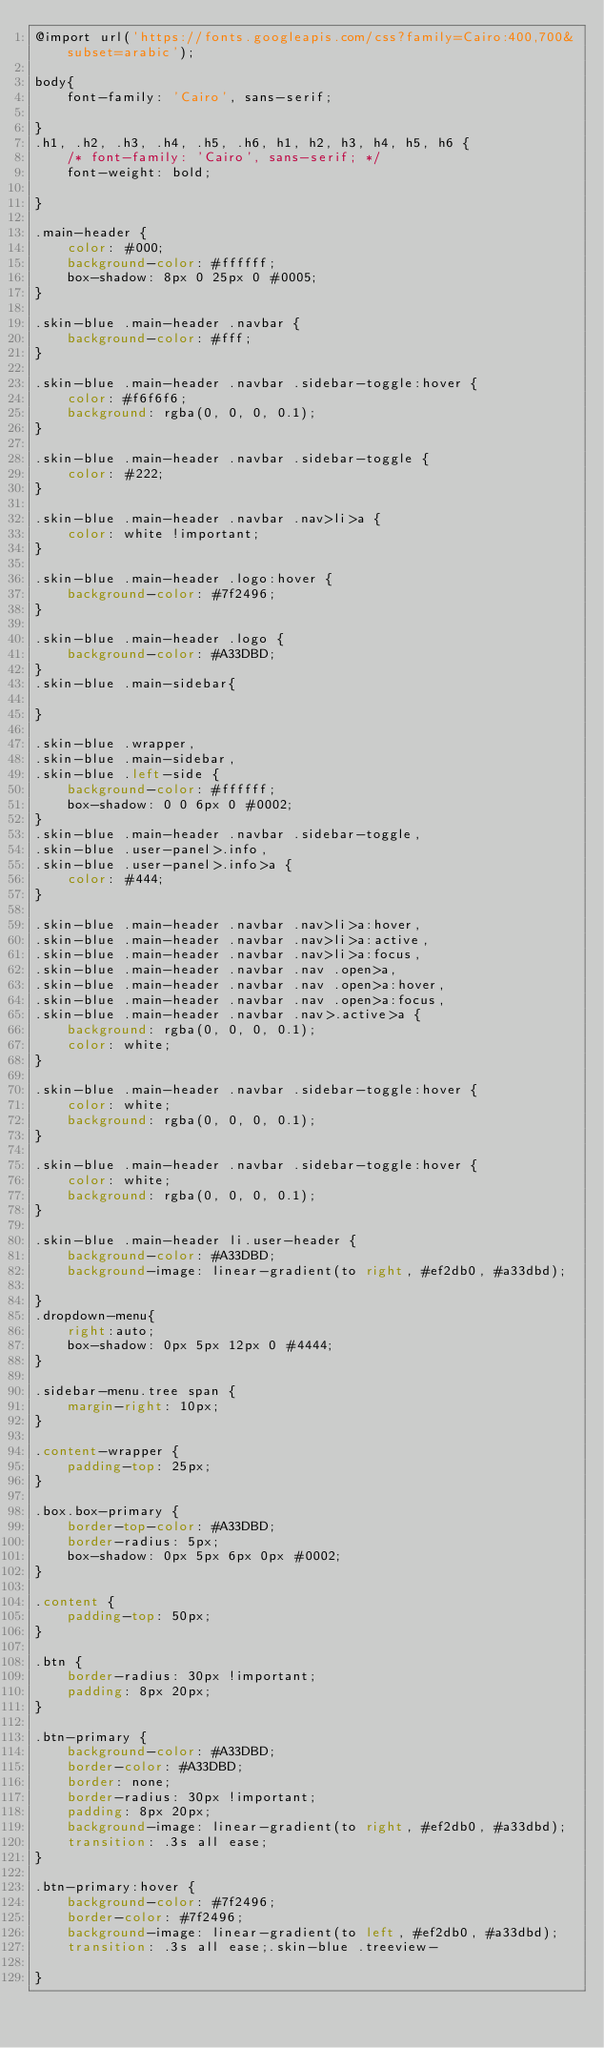<code> <loc_0><loc_0><loc_500><loc_500><_CSS_>@import url('https://fonts.googleapis.com/css?family=Cairo:400,700&subset=arabic');

body{
    font-family: 'Cairo', sans-serif;

}
.h1, .h2, .h3, .h4, .h5, .h6, h1, h2, h3, h4, h5, h6 {
    /* font-family: 'Cairo', sans-serif; */
    font-weight: bold;

}

.main-header {
    color: #000;
    background-color: #ffffff;
    box-shadow: 8px 0 25px 0 #0005;
}

.skin-blue .main-header .navbar {
    background-color: #fff;
}

.skin-blue .main-header .navbar .sidebar-toggle:hover {
    color: #f6f6f6;
    background: rgba(0, 0, 0, 0.1);
}

.skin-blue .main-header .navbar .sidebar-toggle {
    color: #222;
}

.skin-blue .main-header .navbar .nav>li>a {
    color: white !important;
}

.skin-blue .main-header .logo:hover {
    background-color: #7f2496;
}

.skin-blue .main-header .logo {
    background-color: #A33DBD;
}
.skin-blue .main-sidebar{

}

.skin-blue .wrapper,
.skin-blue .main-sidebar,
.skin-blue .left-side {
    background-color: #ffffff;
    box-shadow: 0 0 6px 0 #0002;
}
.skin-blue .main-header .navbar .sidebar-toggle,
.skin-blue .user-panel>.info,
.skin-blue .user-panel>.info>a {
    color: #444;
}

.skin-blue .main-header .navbar .nav>li>a:hover,
.skin-blue .main-header .navbar .nav>li>a:active,
.skin-blue .main-header .navbar .nav>li>a:focus,
.skin-blue .main-header .navbar .nav .open>a,
.skin-blue .main-header .navbar .nav .open>a:hover,
.skin-blue .main-header .navbar .nav .open>a:focus,
.skin-blue .main-header .navbar .nav>.active>a {
    background: rgba(0, 0, 0, 0.1);
    color: white;
}

.skin-blue .main-header .navbar .sidebar-toggle:hover {
    color: white;
    background: rgba(0, 0, 0, 0.1);
}

.skin-blue .main-header .navbar .sidebar-toggle:hover {
    color: white;
    background: rgba(0, 0, 0, 0.1);
}

.skin-blue .main-header li.user-header {
    background-color: #A33DBD;
    background-image: linear-gradient(to right, #ef2db0, #a33dbd);

}
.dropdown-menu{
    right:auto;
    box-shadow: 0px 5px 12px 0 #4444;
}

.sidebar-menu.tree span {
    margin-right: 10px;
}

.content-wrapper {
    padding-top: 25px;
}

.box.box-primary {
    border-top-color: #A33DBD;
    border-radius: 5px;
    box-shadow: 0px 5px 6px 0px #0002;
}

.content {
    padding-top: 50px;
}

.btn {
    border-radius: 30px !important;
    padding: 8px 20px;
}

.btn-primary {
    background-color: #A33DBD;
    border-color: #A33DBD;
    border: none;
    border-radius: 30px !important;
    padding: 8px 20px;
    background-image: linear-gradient(to right, #ef2db0, #a33dbd);
    transition: .3s all ease;
}

.btn-primary:hover {
    background-color: #7f2496;
    border-color: #7f2496;
    background-image: linear-gradient(to left, #ef2db0, #a33dbd);
    transition: .3s all ease;.skin-blue .treeview-

}
</code> 